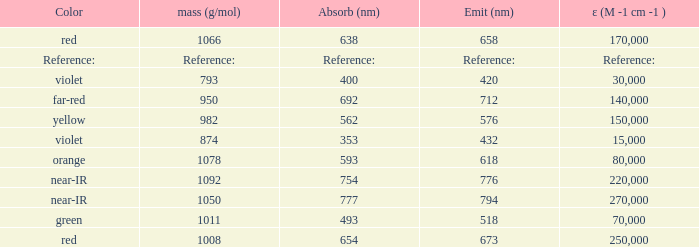Which Emission (in nanometers) that has a molar mass of 1078 g/mol? 618.0. 